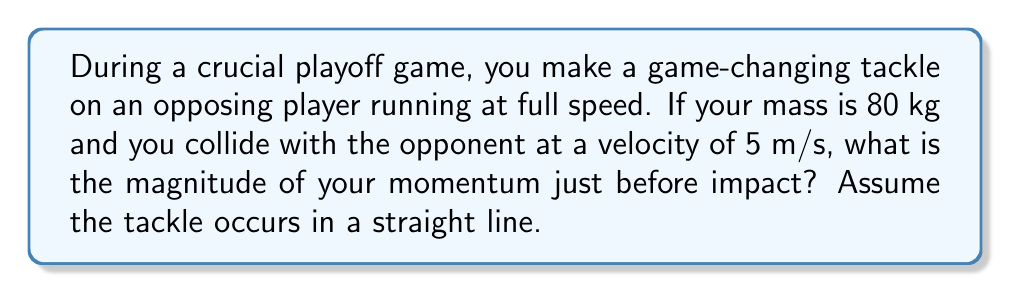What is the answer to this math problem? To solve this problem, we'll use the concept of linear momentum from Newton's laws of motion. The linear momentum of an object is defined as the product of its mass and velocity.

Step 1: Identify the given information
- Your mass: $m = 80$ kg
- Your velocity: $v = 5$ m/s

Step 2: Recall the formula for linear momentum
The linear momentum $p$ is given by:
$$p = mv$$
where $m$ is the mass and $v$ is the velocity.

Step 3: Substitute the values into the formula
$$p = (80 \text{ kg})(5 \text{ m/s})$$

Step 4: Calculate the result
$$p = 400 \text{ kg}\cdot\text{m/s}$$

The magnitude of momentum is always a positive scalar value, so we don't need to consider direction in this case.
Answer: $400 \text{ kg}\cdot\text{m/s}$ 